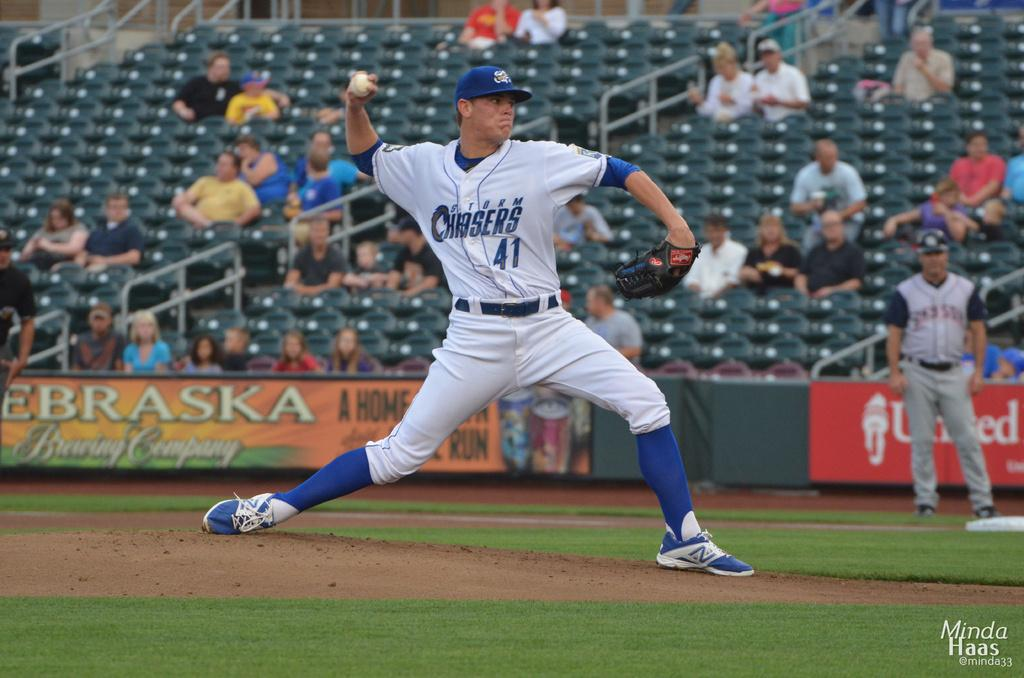<image>
Offer a succinct explanation of the picture presented. number 41 of the Storm Chasers is pitching the ball 